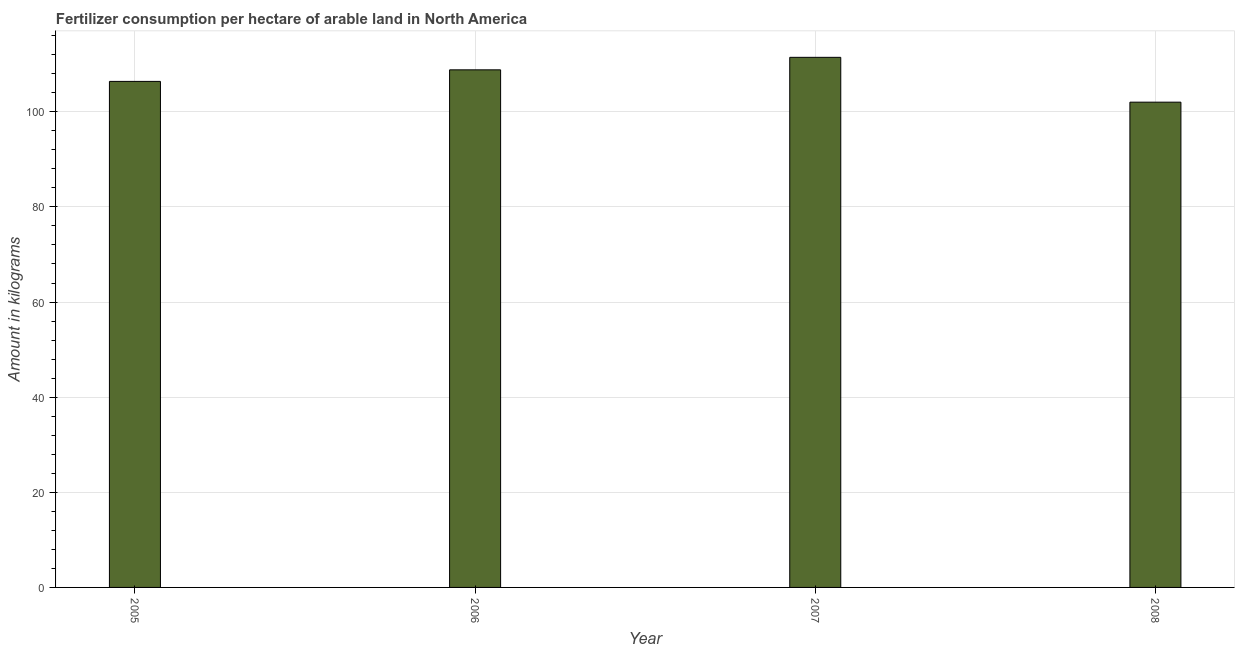What is the title of the graph?
Offer a terse response. Fertilizer consumption per hectare of arable land in North America . What is the label or title of the Y-axis?
Provide a succinct answer. Amount in kilograms. What is the amount of fertilizer consumption in 2005?
Give a very brief answer. 106.38. Across all years, what is the maximum amount of fertilizer consumption?
Your response must be concise. 111.44. Across all years, what is the minimum amount of fertilizer consumption?
Provide a succinct answer. 102.02. In which year was the amount of fertilizer consumption maximum?
Provide a short and direct response. 2007. What is the sum of the amount of fertilizer consumption?
Your answer should be very brief. 428.66. What is the difference between the amount of fertilizer consumption in 2007 and 2008?
Your answer should be very brief. 9.43. What is the average amount of fertilizer consumption per year?
Make the answer very short. 107.17. What is the median amount of fertilizer consumption?
Provide a succinct answer. 107.6. In how many years, is the amount of fertilizer consumption greater than 20 kg?
Your response must be concise. 4. Do a majority of the years between 2007 and 2005 (inclusive) have amount of fertilizer consumption greater than 56 kg?
Provide a short and direct response. Yes. What is the ratio of the amount of fertilizer consumption in 2007 to that in 2008?
Make the answer very short. 1.09. What is the difference between the highest and the second highest amount of fertilizer consumption?
Provide a succinct answer. 2.63. Is the sum of the amount of fertilizer consumption in 2005 and 2008 greater than the maximum amount of fertilizer consumption across all years?
Give a very brief answer. Yes. What is the difference between the highest and the lowest amount of fertilizer consumption?
Give a very brief answer. 9.42. How many bars are there?
Offer a very short reply. 4. What is the difference between two consecutive major ticks on the Y-axis?
Offer a terse response. 20. Are the values on the major ticks of Y-axis written in scientific E-notation?
Your answer should be compact. No. What is the Amount in kilograms in 2005?
Provide a succinct answer. 106.38. What is the Amount in kilograms in 2006?
Make the answer very short. 108.81. What is the Amount in kilograms in 2007?
Provide a succinct answer. 111.44. What is the Amount in kilograms in 2008?
Make the answer very short. 102.02. What is the difference between the Amount in kilograms in 2005 and 2006?
Your answer should be compact. -2.43. What is the difference between the Amount in kilograms in 2005 and 2007?
Your answer should be very brief. -5.06. What is the difference between the Amount in kilograms in 2005 and 2008?
Your answer should be compact. 4.36. What is the difference between the Amount in kilograms in 2006 and 2007?
Provide a short and direct response. -2.63. What is the difference between the Amount in kilograms in 2006 and 2008?
Provide a succinct answer. 6.79. What is the difference between the Amount in kilograms in 2007 and 2008?
Provide a succinct answer. 9.42. What is the ratio of the Amount in kilograms in 2005 to that in 2006?
Give a very brief answer. 0.98. What is the ratio of the Amount in kilograms in 2005 to that in 2007?
Offer a very short reply. 0.95. What is the ratio of the Amount in kilograms in 2005 to that in 2008?
Provide a short and direct response. 1.04. What is the ratio of the Amount in kilograms in 2006 to that in 2008?
Make the answer very short. 1.07. What is the ratio of the Amount in kilograms in 2007 to that in 2008?
Provide a short and direct response. 1.09. 